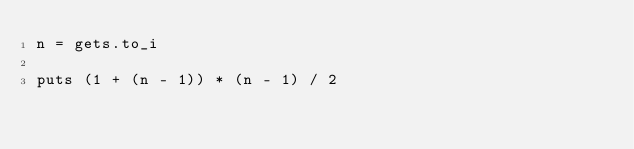<code> <loc_0><loc_0><loc_500><loc_500><_Ruby_>n = gets.to_i

puts (1 + (n - 1)) * (n - 1) / 2
</code> 